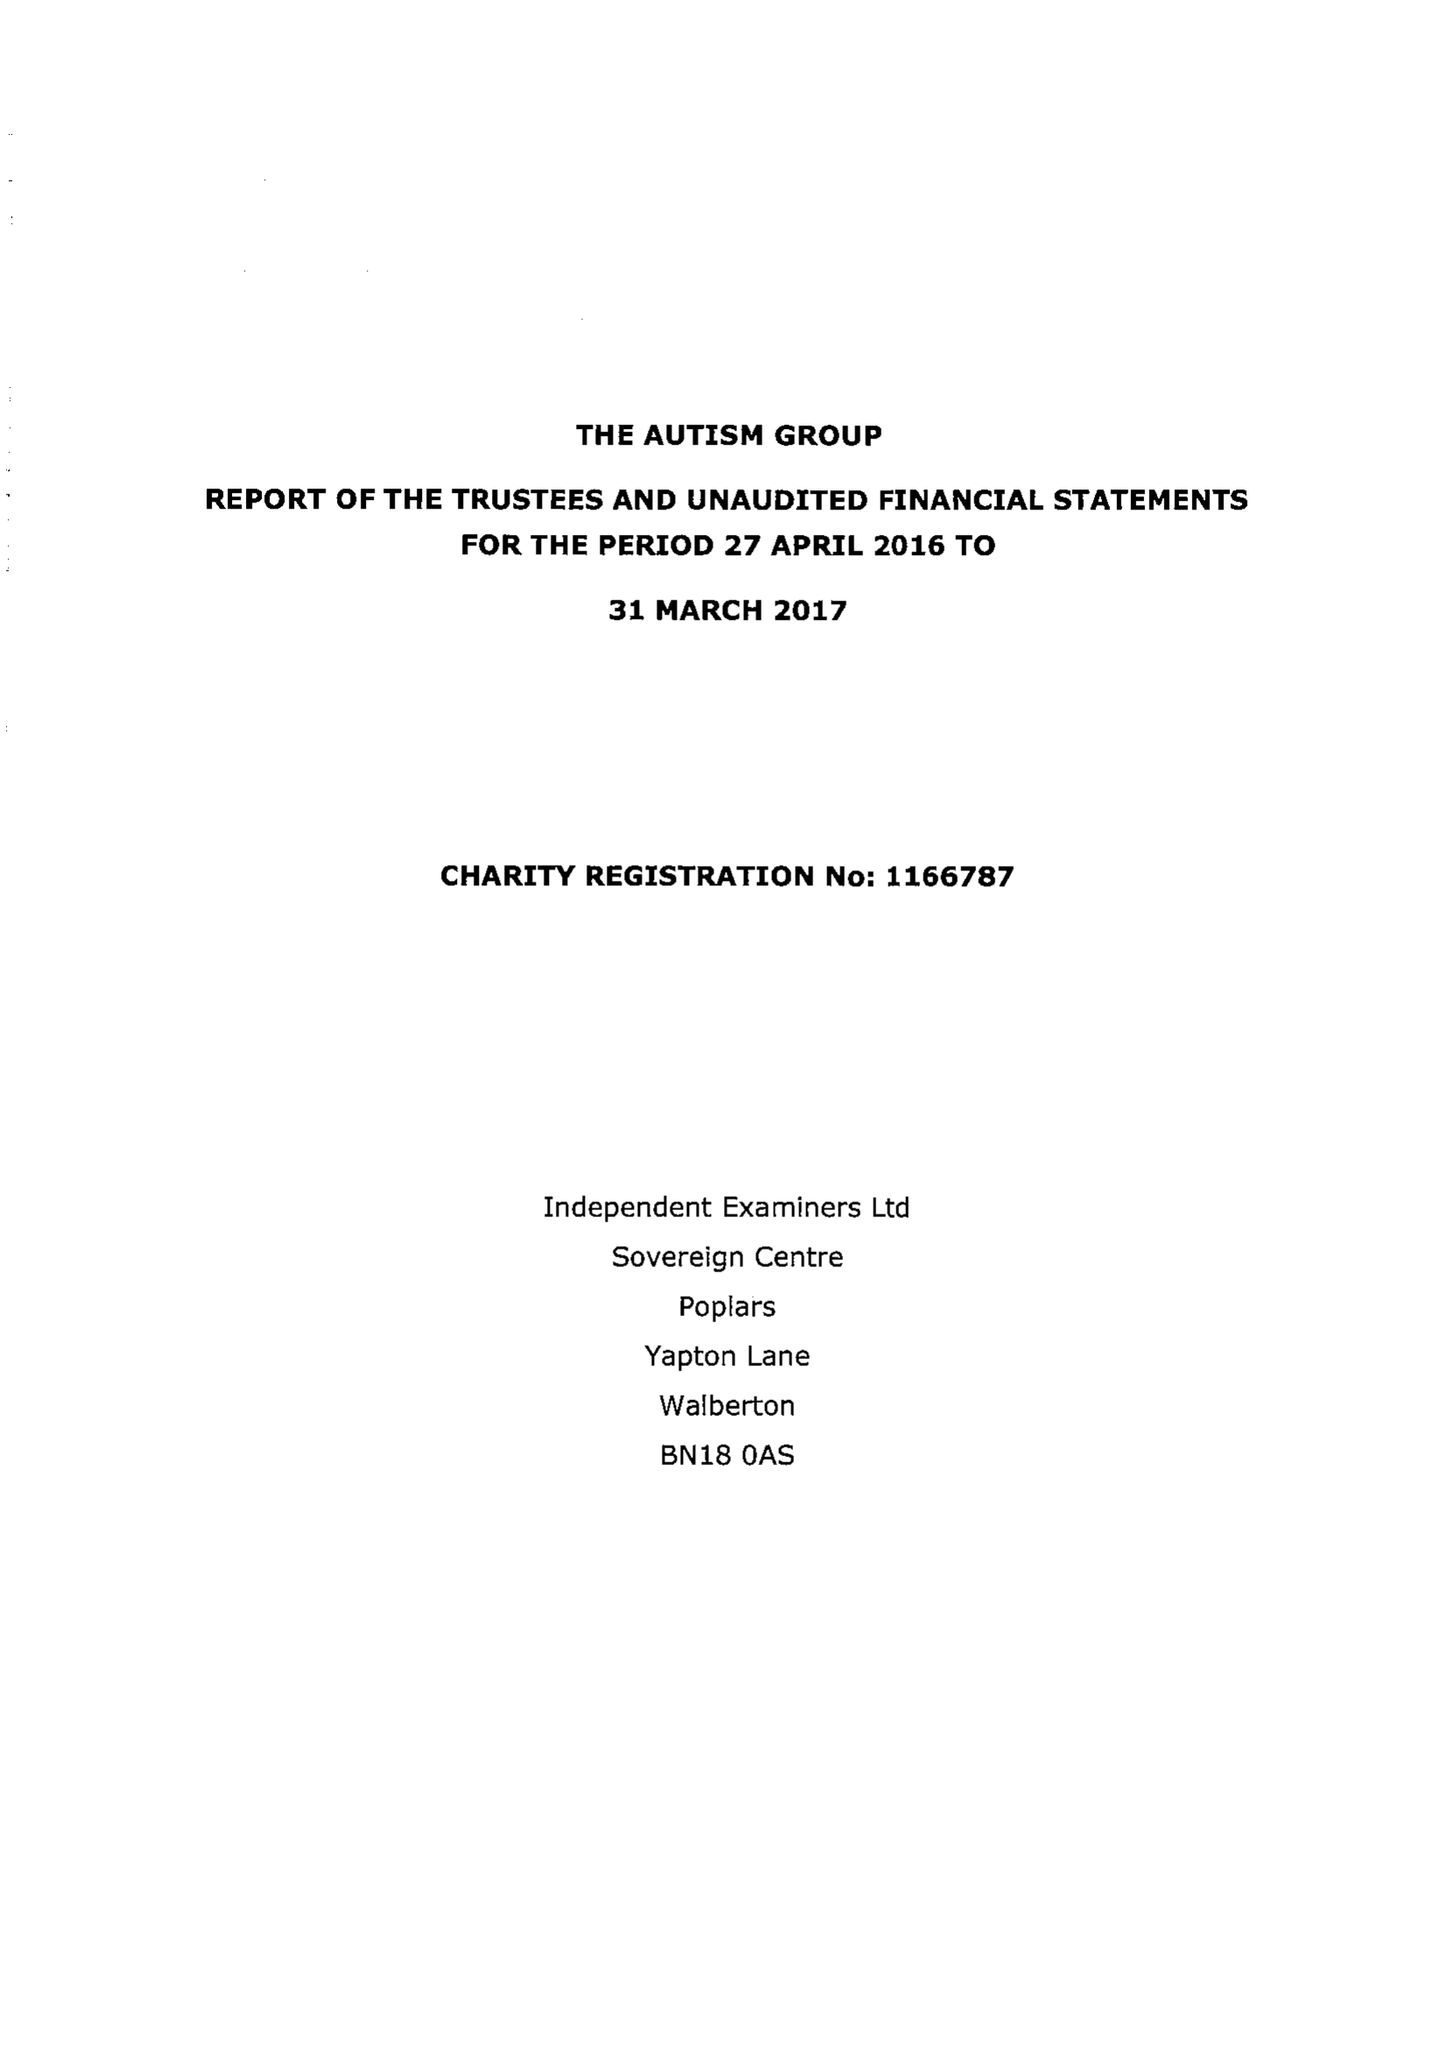What is the value for the report_date?
Answer the question using a single word or phrase. 2017-03-31 